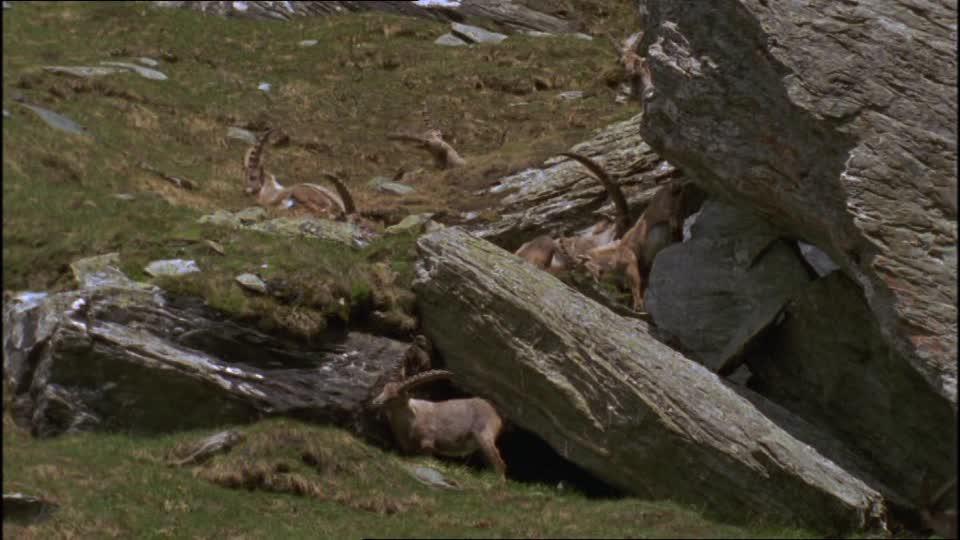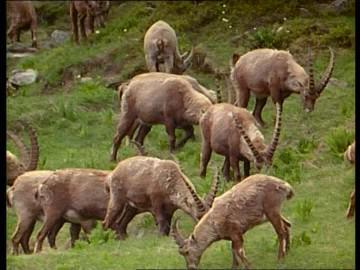The first image is the image on the left, the second image is the image on the right. Given the left and right images, does the statement "Right image shows multiple horned animals grazing, with lowered heads." hold true? Answer yes or no. Yes. The first image is the image on the left, the second image is the image on the right. Evaluate the accuracy of this statement regarding the images: "There are no rocks near some of the animals.". Is it true? Answer yes or no. Yes. 